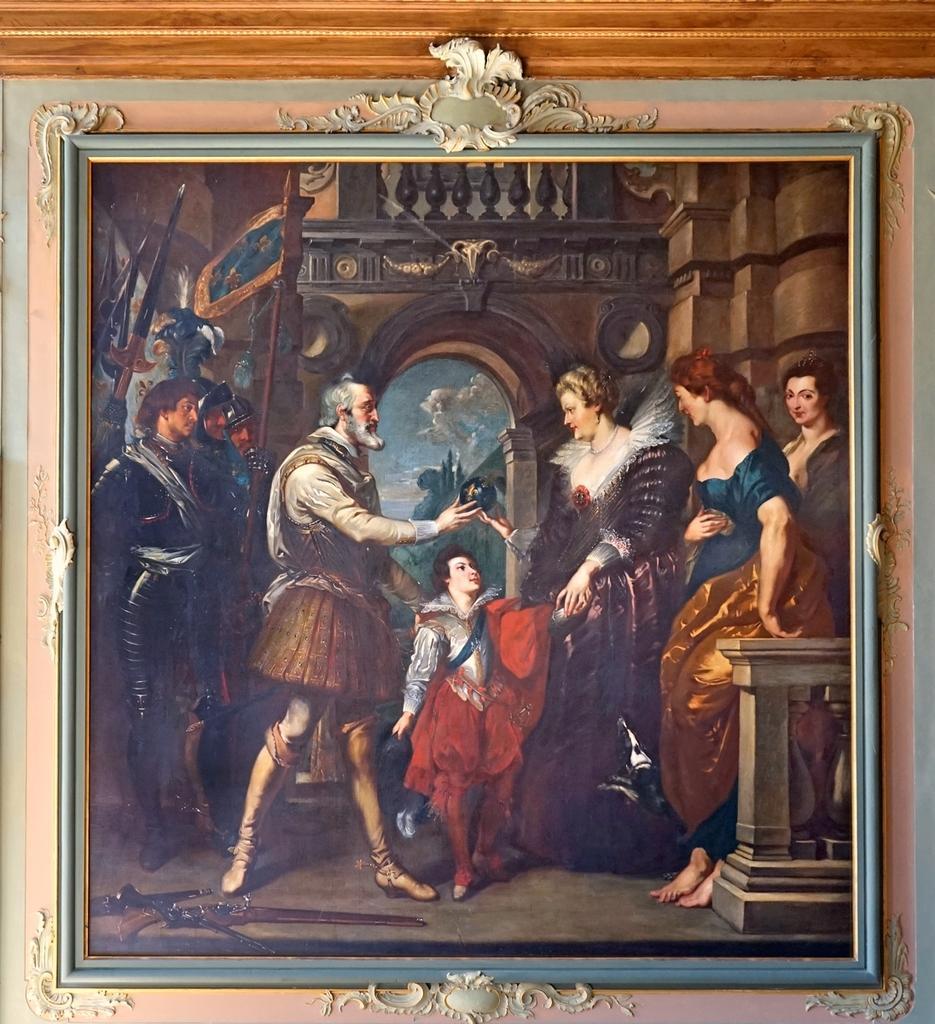Could you give a brief overview of what you see in this image? This picture shows a painting and we see few men and women and a girl in the painting. 